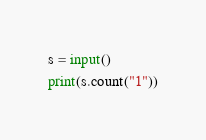Convert code to text. <code><loc_0><loc_0><loc_500><loc_500><_Python_>s = input()
print(s.count("1"))</code> 